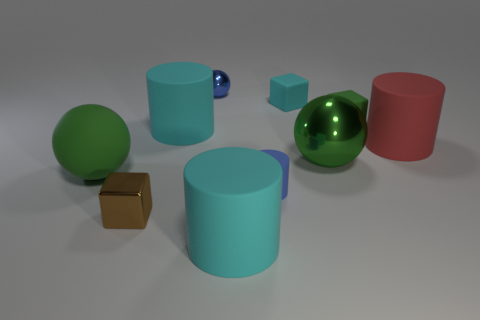How does the lighting affect the appearance of objects in this image? The lighting in the image creates a soft shadow on the objects, enhancing their three-dimensional shape and highlighting their textural differences. The metallic objects reflect light strongly and show highlights, whereas the matte objects absorb light, giving a softer appearance. 